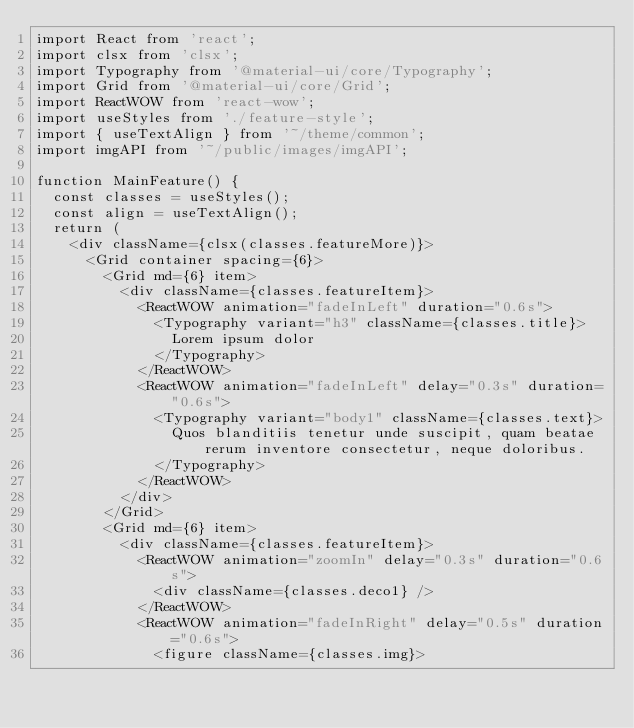Convert code to text. <code><loc_0><loc_0><loc_500><loc_500><_JavaScript_>import React from 'react';
import clsx from 'clsx';
import Typography from '@material-ui/core/Typography';
import Grid from '@material-ui/core/Grid';
import ReactWOW from 'react-wow';
import useStyles from './feature-style';
import { useTextAlign } from '~/theme/common';
import imgAPI from '~/public/images/imgAPI';

function MainFeature() {
  const classes = useStyles();
  const align = useTextAlign();
  return (
    <div className={clsx(classes.featureMore)}>
      <Grid container spacing={6}>
        <Grid md={6} item>
          <div className={classes.featureItem}>
            <ReactWOW animation="fadeInLeft" duration="0.6s">
              <Typography variant="h3" className={classes.title}>
                Lorem ipsum dolor
              </Typography>
            </ReactWOW>
            <ReactWOW animation="fadeInLeft" delay="0.3s" duration="0.6s">
              <Typography variant="body1" className={classes.text}>
                Quos blanditiis tenetur unde suscipit, quam beatae rerum inventore consectetur, neque doloribus.
              </Typography>
            </ReactWOW>
          </div>
        </Grid>
        <Grid md={6} item>
          <div className={classes.featureItem}>
            <ReactWOW animation="zoomIn" delay="0.3s" duration="0.6s">
              <div className={classes.deco1} />
            </ReactWOW>
            <ReactWOW animation="fadeInRight" delay="0.5s" duration="0.6s">
              <figure className={classes.img}></code> 